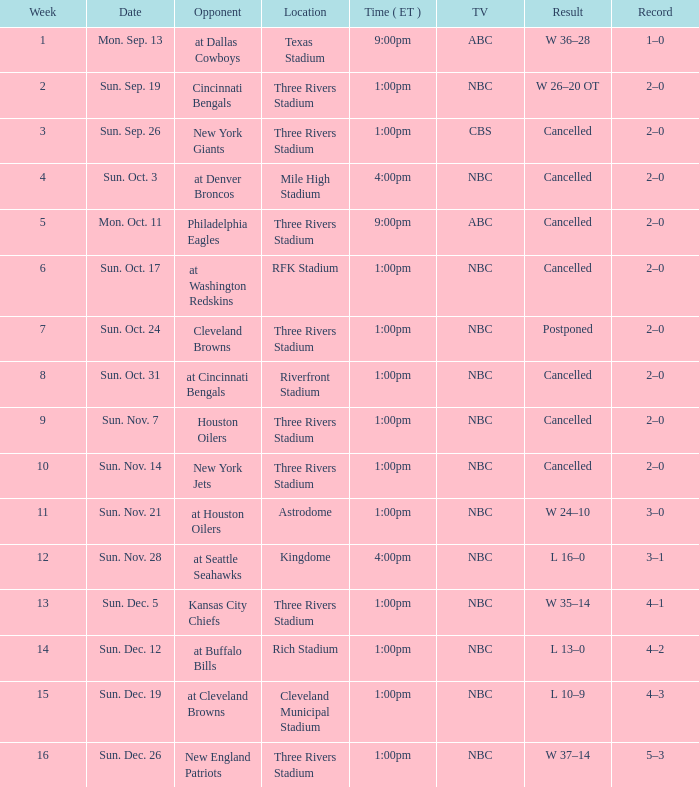When, in eastern standard time, was the match conducted at denver broncos? 4:00pm. 